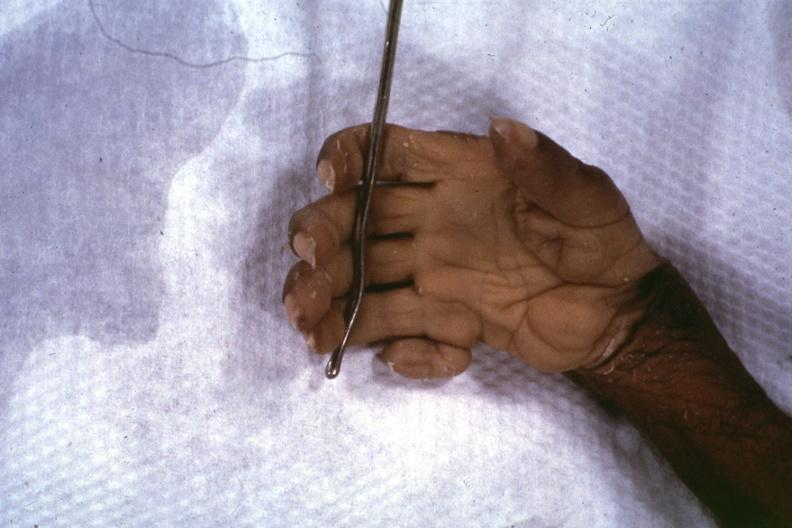does this image show close-up supernumerary digit?
Answer the question using a single word or phrase. This 